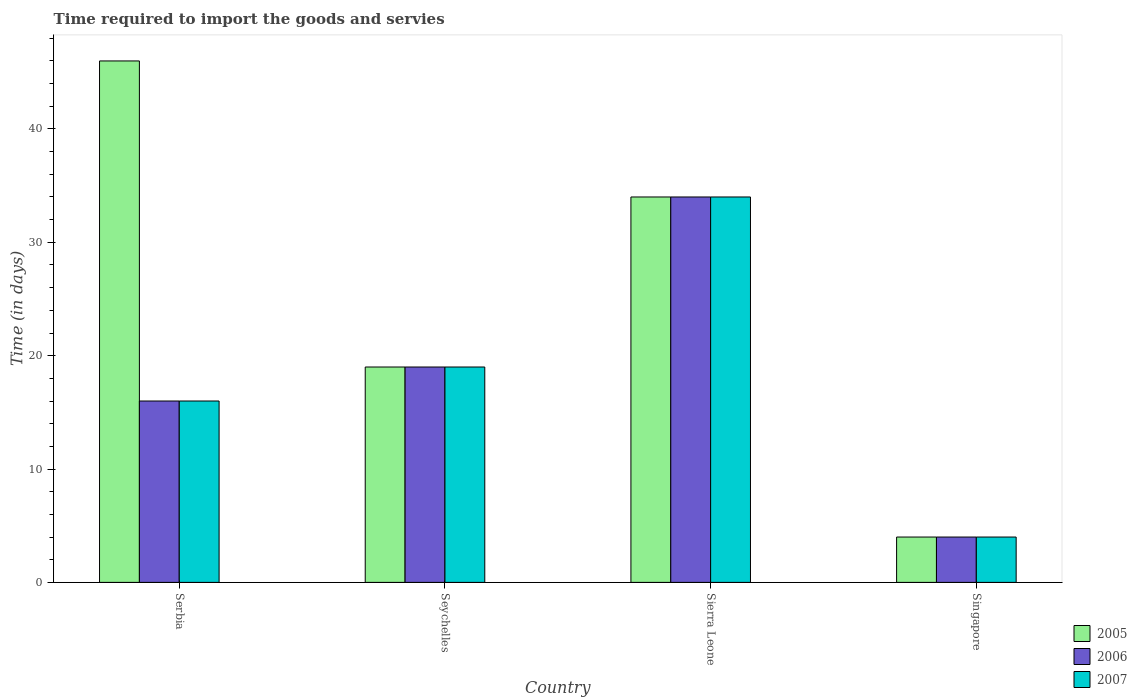How many groups of bars are there?
Provide a short and direct response. 4. Are the number of bars on each tick of the X-axis equal?
Your answer should be compact. Yes. How many bars are there on the 2nd tick from the left?
Your answer should be compact. 3. How many bars are there on the 3rd tick from the right?
Offer a terse response. 3. What is the label of the 2nd group of bars from the left?
Provide a succinct answer. Seychelles. In how many cases, is the number of bars for a given country not equal to the number of legend labels?
Your response must be concise. 0. Across all countries, what is the maximum number of days required to import the goods and services in 2007?
Provide a short and direct response. 34. In which country was the number of days required to import the goods and services in 2007 maximum?
Offer a terse response. Sierra Leone. In which country was the number of days required to import the goods and services in 2006 minimum?
Offer a terse response. Singapore. What is the average number of days required to import the goods and services in 2007 per country?
Provide a short and direct response. 18.25. What is the ratio of the number of days required to import the goods and services in 2005 in Seychelles to that in Singapore?
Provide a succinct answer. 4.75. Are all the bars in the graph horizontal?
Ensure brevity in your answer.  No. What is the difference between two consecutive major ticks on the Y-axis?
Ensure brevity in your answer.  10. Does the graph contain any zero values?
Provide a succinct answer. No. Does the graph contain grids?
Your answer should be very brief. No. Where does the legend appear in the graph?
Keep it short and to the point. Bottom right. How many legend labels are there?
Provide a short and direct response. 3. What is the title of the graph?
Your answer should be very brief. Time required to import the goods and servies. What is the label or title of the X-axis?
Your answer should be compact. Country. What is the label or title of the Y-axis?
Offer a terse response. Time (in days). What is the Time (in days) of 2005 in Serbia?
Your response must be concise. 46. What is the Time (in days) in 2006 in Serbia?
Keep it short and to the point. 16. What is the Time (in days) of 2007 in Serbia?
Make the answer very short. 16. What is the Time (in days) in 2005 in Sierra Leone?
Your response must be concise. 34. What is the Time (in days) of 2006 in Sierra Leone?
Provide a succinct answer. 34. What is the Time (in days) of 2007 in Sierra Leone?
Give a very brief answer. 34. What is the Time (in days) in 2006 in Singapore?
Provide a short and direct response. 4. What is the Time (in days) of 2007 in Singapore?
Make the answer very short. 4. Across all countries, what is the maximum Time (in days) in 2005?
Provide a succinct answer. 46. Across all countries, what is the maximum Time (in days) in 2006?
Give a very brief answer. 34. Across all countries, what is the maximum Time (in days) in 2007?
Make the answer very short. 34. Across all countries, what is the minimum Time (in days) in 2006?
Provide a short and direct response. 4. Across all countries, what is the minimum Time (in days) of 2007?
Keep it short and to the point. 4. What is the total Time (in days) of 2005 in the graph?
Make the answer very short. 103. What is the total Time (in days) in 2006 in the graph?
Your response must be concise. 73. What is the difference between the Time (in days) in 2006 in Serbia and that in Seychelles?
Your response must be concise. -3. What is the difference between the Time (in days) in 2005 in Serbia and that in Sierra Leone?
Your answer should be very brief. 12. What is the difference between the Time (in days) in 2006 in Serbia and that in Sierra Leone?
Offer a terse response. -18. What is the difference between the Time (in days) of 2007 in Serbia and that in Sierra Leone?
Give a very brief answer. -18. What is the difference between the Time (in days) in 2005 in Serbia and that in Singapore?
Your response must be concise. 42. What is the difference between the Time (in days) of 2006 in Serbia and that in Singapore?
Your answer should be compact. 12. What is the difference between the Time (in days) of 2007 in Serbia and that in Singapore?
Provide a succinct answer. 12. What is the difference between the Time (in days) in 2005 in Seychelles and that in Sierra Leone?
Offer a terse response. -15. What is the difference between the Time (in days) in 2007 in Seychelles and that in Sierra Leone?
Your answer should be very brief. -15. What is the difference between the Time (in days) in 2005 in Seychelles and that in Singapore?
Provide a short and direct response. 15. What is the difference between the Time (in days) in 2007 in Seychelles and that in Singapore?
Your response must be concise. 15. What is the difference between the Time (in days) in 2005 in Sierra Leone and that in Singapore?
Make the answer very short. 30. What is the difference between the Time (in days) of 2006 in Sierra Leone and that in Singapore?
Keep it short and to the point. 30. What is the difference between the Time (in days) in 2007 in Sierra Leone and that in Singapore?
Your answer should be very brief. 30. What is the difference between the Time (in days) in 2005 in Serbia and the Time (in days) in 2006 in Seychelles?
Offer a terse response. 27. What is the difference between the Time (in days) in 2005 in Serbia and the Time (in days) in 2007 in Seychelles?
Offer a very short reply. 27. What is the difference between the Time (in days) in 2005 in Serbia and the Time (in days) in 2006 in Sierra Leone?
Provide a short and direct response. 12. What is the difference between the Time (in days) in 2005 in Serbia and the Time (in days) in 2007 in Sierra Leone?
Offer a terse response. 12. What is the difference between the Time (in days) in 2005 in Serbia and the Time (in days) in 2007 in Singapore?
Provide a succinct answer. 42. What is the difference between the Time (in days) in 2005 in Seychelles and the Time (in days) in 2006 in Sierra Leone?
Keep it short and to the point. -15. What is the difference between the Time (in days) in 2005 in Sierra Leone and the Time (in days) in 2007 in Singapore?
Ensure brevity in your answer.  30. What is the average Time (in days) of 2005 per country?
Your answer should be compact. 25.75. What is the average Time (in days) in 2006 per country?
Give a very brief answer. 18.25. What is the average Time (in days) of 2007 per country?
Give a very brief answer. 18.25. What is the difference between the Time (in days) in 2005 and Time (in days) in 2006 in Seychelles?
Provide a succinct answer. 0. What is the difference between the Time (in days) in 2006 and Time (in days) in 2007 in Sierra Leone?
Offer a terse response. 0. What is the difference between the Time (in days) of 2005 and Time (in days) of 2007 in Singapore?
Give a very brief answer. 0. What is the ratio of the Time (in days) in 2005 in Serbia to that in Seychelles?
Your response must be concise. 2.42. What is the ratio of the Time (in days) of 2006 in Serbia to that in Seychelles?
Give a very brief answer. 0.84. What is the ratio of the Time (in days) of 2007 in Serbia to that in Seychelles?
Provide a short and direct response. 0.84. What is the ratio of the Time (in days) of 2005 in Serbia to that in Sierra Leone?
Offer a terse response. 1.35. What is the ratio of the Time (in days) of 2006 in Serbia to that in Sierra Leone?
Your answer should be very brief. 0.47. What is the ratio of the Time (in days) in 2007 in Serbia to that in Sierra Leone?
Your answer should be compact. 0.47. What is the ratio of the Time (in days) of 2005 in Serbia to that in Singapore?
Offer a terse response. 11.5. What is the ratio of the Time (in days) of 2005 in Seychelles to that in Sierra Leone?
Your answer should be very brief. 0.56. What is the ratio of the Time (in days) in 2006 in Seychelles to that in Sierra Leone?
Give a very brief answer. 0.56. What is the ratio of the Time (in days) of 2007 in Seychelles to that in Sierra Leone?
Give a very brief answer. 0.56. What is the ratio of the Time (in days) in 2005 in Seychelles to that in Singapore?
Your answer should be compact. 4.75. What is the ratio of the Time (in days) in 2006 in Seychelles to that in Singapore?
Offer a terse response. 4.75. What is the ratio of the Time (in days) in 2007 in Seychelles to that in Singapore?
Your answer should be very brief. 4.75. What is the ratio of the Time (in days) of 2005 in Sierra Leone to that in Singapore?
Make the answer very short. 8.5. What is the ratio of the Time (in days) in 2007 in Sierra Leone to that in Singapore?
Provide a short and direct response. 8.5. What is the difference between the highest and the second highest Time (in days) in 2006?
Your answer should be very brief. 15. What is the difference between the highest and the second highest Time (in days) in 2007?
Provide a succinct answer. 15. What is the difference between the highest and the lowest Time (in days) of 2005?
Ensure brevity in your answer.  42. What is the difference between the highest and the lowest Time (in days) in 2006?
Make the answer very short. 30. What is the difference between the highest and the lowest Time (in days) of 2007?
Offer a very short reply. 30. 